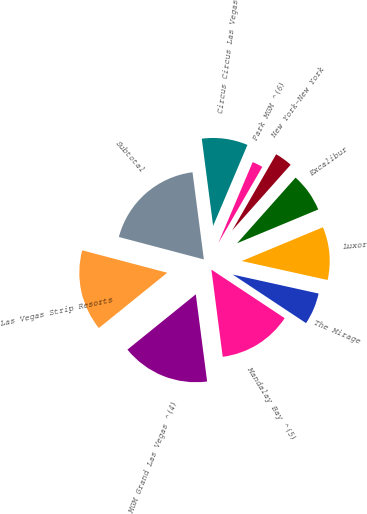Convert chart to OTSL. <chart><loc_0><loc_0><loc_500><loc_500><pie_chart><fcel>Las Vegas Strip Resorts<fcel>MGM Grand Las Vegas ^(4)<fcel>Mandalay Bay ^(5)<fcel>The Mirage<fcel>Luxor<fcel>Excalibur<fcel>New York-New York<fcel>Park MGM ^(6)<fcel>Circus Circus Las Vegas<fcel>Subtotal<nl><fcel>14.93%<fcel>16.23%<fcel>13.63%<fcel>5.85%<fcel>9.74%<fcel>7.14%<fcel>3.25%<fcel>1.95%<fcel>8.44%<fcel>18.83%<nl></chart> 